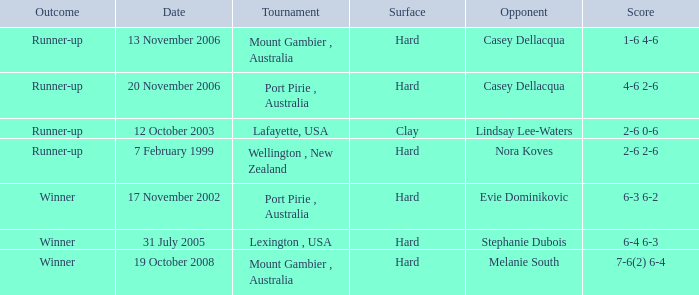Could you parse the entire table? {'header': ['Outcome', 'Date', 'Tournament', 'Surface', 'Opponent', 'Score'], 'rows': [['Runner-up', '13 November 2006', 'Mount Gambier , Australia', 'Hard', 'Casey Dellacqua', '1-6 4-6'], ['Runner-up', '20 November 2006', 'Port Pirie , Australia', 'Hard', 'Casey Dellacqua', '4-6 2-6'], ['Runner-up', '12 October 2003', 'Lafayette, USA', 'Clay', 'Lindsay Lee-Waters', '2-6 0-6'], ['Runner-up', '7 February 1999', 'Wellington , New Zealand', 'Hard', 'Nora Koves', '2-6 2-6'], ['Winner', '17 November 2002', 'Port Pirie , Australia', 'Hard', 'Evie Dominikovic', '6-3 6-2'], ['Winner', '31 July 2005', 'Lexington , USA', 'Hard', 'Stephanie Dubois', '6-4 6-3'], ['Winner', '19 October 2008', 'Mount Gambier , Australia', 'Hard', 'Melanie South', '7-6(2) 6-4']]} When is an adversary of evie dominikovic? 17 November 2002. 